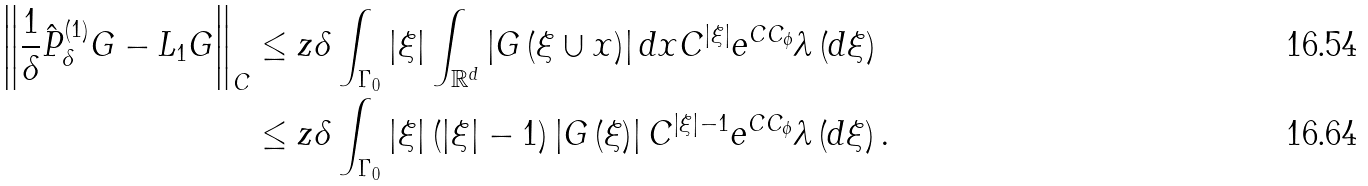Convert formula to latex. <formula><loc_0><loc_0><loc_500><loc_500>\left \| \frac { 1 } { \delta } \hat { P } _ { \delta } ^ { \left ( 1 \right ) } G - L _ { 1 } G \right \| _ { C } & \leq z \delta \int _ { \Gamma _ { 0 } } \left | \xi \right | \int _ { { { \mathbb { R } } ^ { d } } } \left | G \left ( \xi \cup x \right ) \right | d x C ^ { \left | \xi \right | } e ^ { C C _ { \phi } } \lambda \left ( d \xi \right ) \\ & \leq z \delta \int _ { \Gamma _ { 0 } } \left | \xi \right | \left ( \left | \xi \right | - 1 \right ) \left | G \left ( \xi \right ) \right | C ^ { \left | \xi \right | - 1 } e ^ { C C _ { \phi } } \lambda \left ( d \xi \right ) .</formula> 